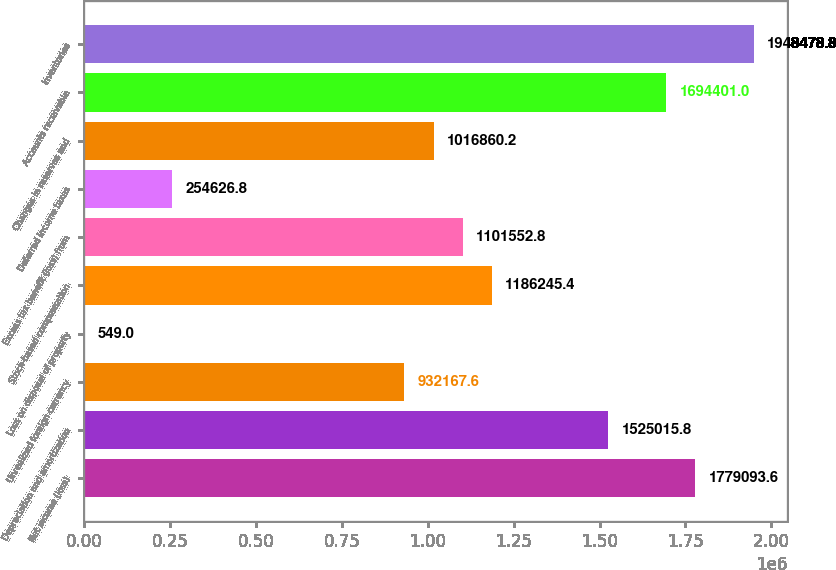<chart> <loc_0><loc_0><loc_500><loc_500><bar_chart><fcel>Net income (loss)<fcel>Depreciation and amortization<fcel>Unrealized foreign currency<fcel>Loss on disposal of property<fcel>Stock-based compensation<fcel>Excess tax benefit (loss) from<fcel>Deferred income taxes<fcel>Changes in reserves and<fcel>Accounts receivable<fcel>Inventories<nl><fcel>1.77909e+06<fcel>1.52502e+06<fcel>932168<fcel>549<fcel>1.18625e+06<fcel>1.10155e+06<fcel>254627<fcel>1.01686e+06<fcel>1.6944e+06<fcel>1.94848e+06<nl></chart> 